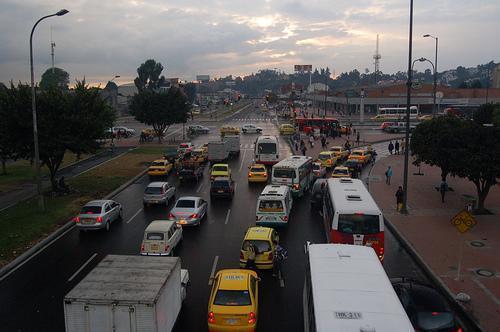How many buses are there?
Give a very brief answer. 2. How many cars are in the picture?
Give a very brief answer. 2. 